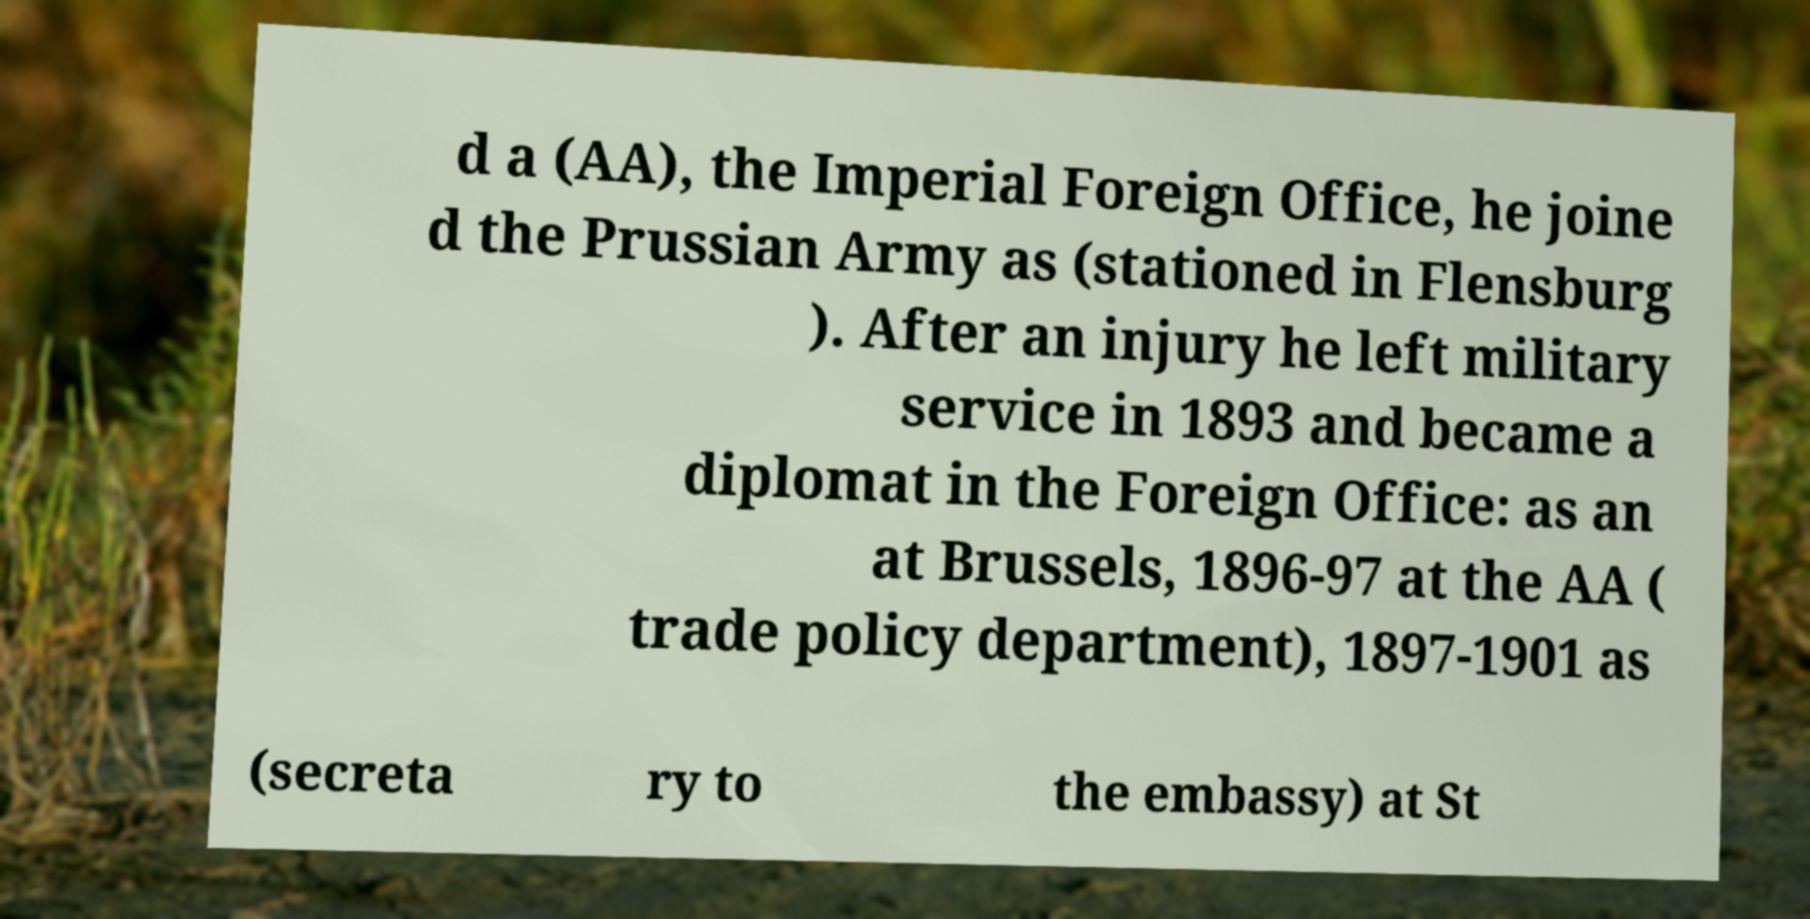I need the written content from this picture converted into text. Can you do that? d a (AA), the Imperial Foreign Office, he joine d the Prussian Army as (stationed in Flensburg ). After an injury he left military service in 1893 and became a diplomat in the Foreign Office: as an at Brussels, 1896-97 at the AA ( trade policy department), 1897-1901 as (secreta ry to the embassy) at St 